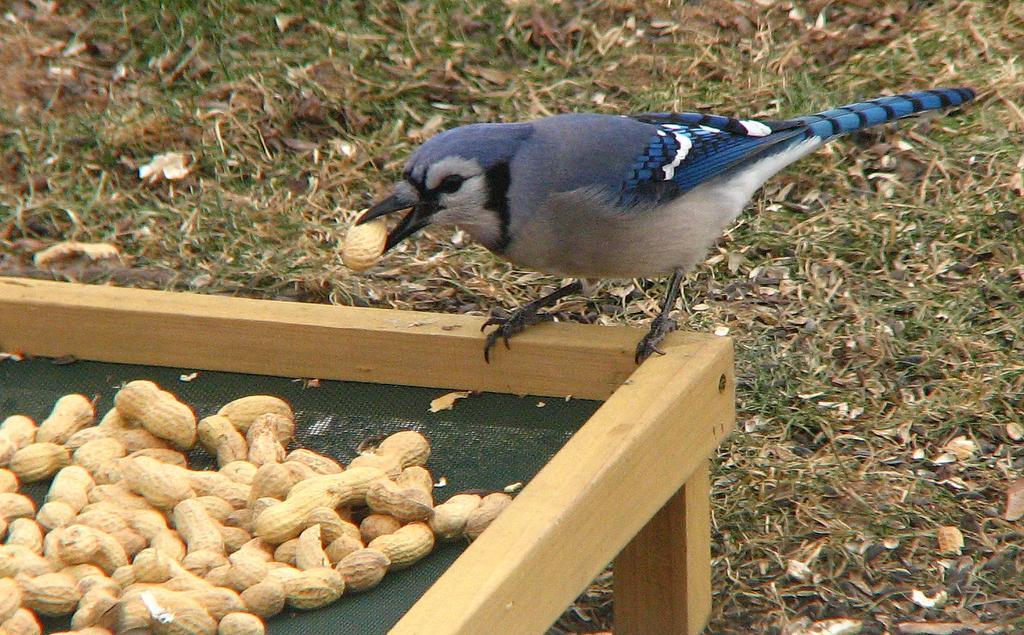Please provide a concise description of this image. In this image there is a bird standing on the wooden table. On top of the wooden table there are peanuts. On the bottom of the image there is grass on the surface. 